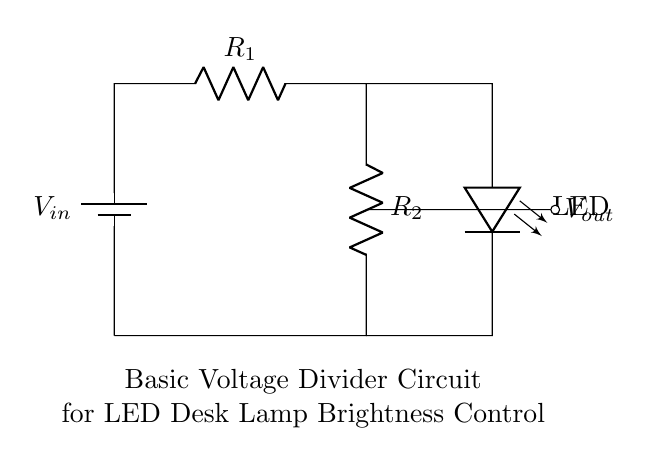What is the purpose of the resistors in this circuit? The resistors in this voltage divider circuit serve to divide the input voltage, allowing the output voltage to be less than the input voltage. This adjustment helps control the brightness of the LED by limiting the current that flows through it.
Answer: Voltage reduction What is the total number of components in the circuit? The circuit consists of three main components: one battery, two resistors, and one LED. By counting each of these elements, we can determine the total number.
Answer: Four What is the location of the output voltage in the circuit? The output voltage can be found at the junction between the two resistors (R1 and R2), where the voltage is taken before it connects to the LED. This point is critical as it determines the brightness based on the division of voltage.
Answer: Between R1 and R2 How does changing the value of R1 affect the LED brightness? Increasing the resistance of R1 will lower the output voltage (Vout) at the junction between R1 and R2. Since the LED brightness is directly proportional to the current flowing through it, a higher R1 results in a dimmer LED. Conversely, decreasing R1 increases Vout and the LED brightness.
Answer: Dims the LED What type of circuit is this diagram representing? This diagram represents a basic voltage divider circuit, which is specifically used to control the brightness of an LED desk lamp by adjusting the output voltage through two resistors. The circuit utilizes the voltage divider principle to achieve its function.
Answer: Voltage divider circuit What would happen if R2 is removed from the circuit? Removing R2 would create a direct connection between the output and the ground, leading to a short circuit condition. This change would prevent the voltage from being divided, likely causing the LED to either burn out or receive excessive current, which is detrimental.
Answer: Short circuit 